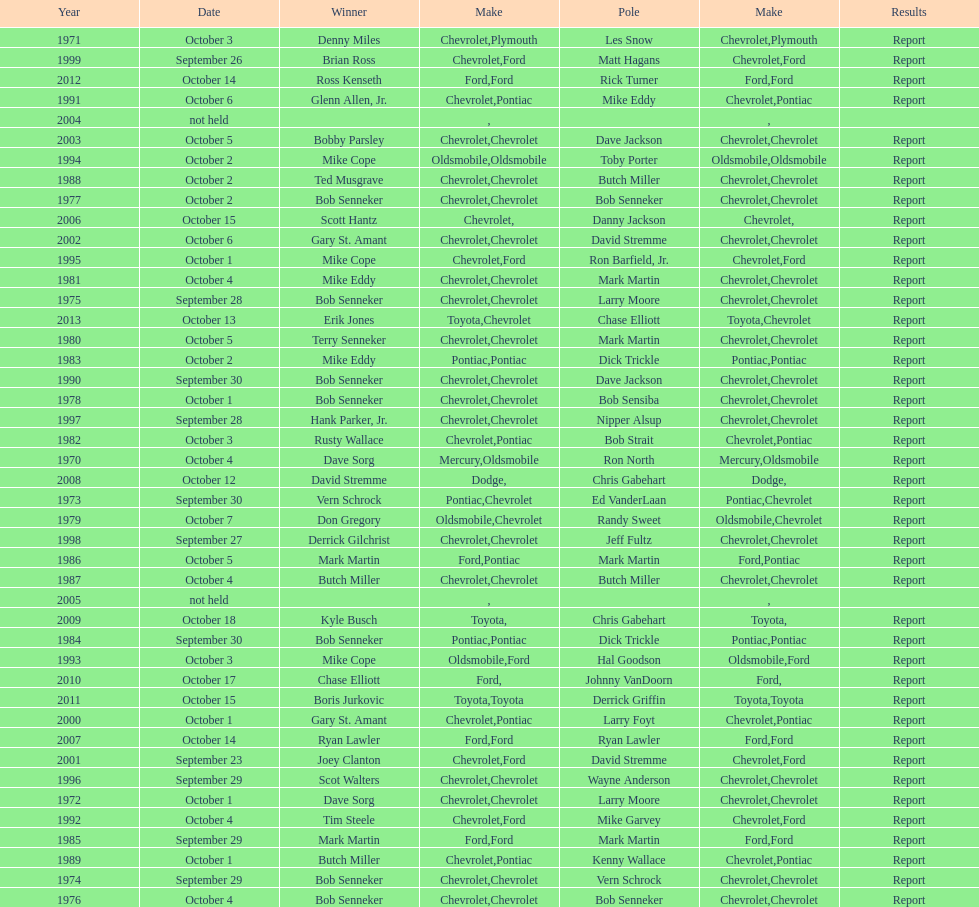Who on the list has the highest number of consecutive wins? Bob Senneker. 